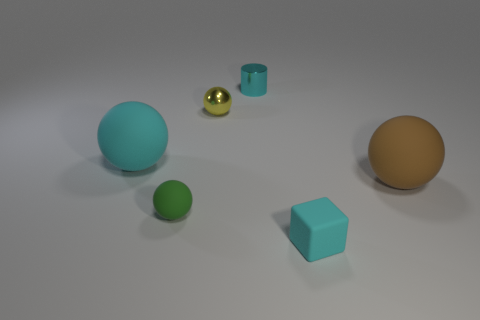Add 3 cyan cylinders. How many objects exist? 9 Subtract all spheres. How many objects are left? 2 Subtract all tiny things. Subtract all tiny green matte balls. How many objects are left? 1 Add 1 small shiny cylinders. How many small shiny cylinders are left? 2 Add 5 cyan cylinders. How many cyan cylinders exist? 6 Subtract 1 brown balls. How many objects are left? 5 